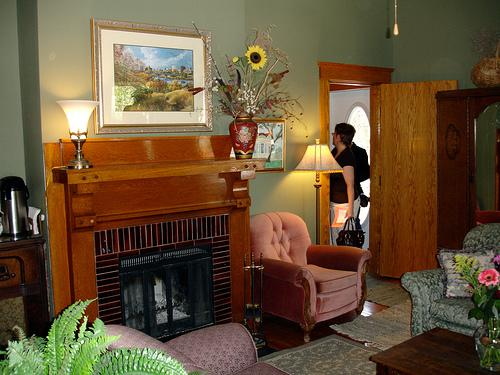Question: what color walls?
Choices:
A. Brown.
B. Green.
C. Tan.
D. White.
Answer with the letter. Answer: B Question: where is pink flower?
Choices:
A. Over the fireplace.
B. On the dresser.
C. On table.
D. In the window.
Answer with the letter. Answer: C Question: what is above fireplace?
Choices:
A. Flowers.
B. Painting.
C. An urn.
D. A clock.
Answer with the letter. Answer: B Question: where is sunflower?
Choices:
A. In window.
B. In a planter.
C. On the nightstand.
D. On mantle.
Answer with the letter. Answer: D Question: where woman standing?
Choices:
A. In the bedroom.
B. Doorway.
C. Over a bathroom sink.
D. By the stove.
Answer with the letter. Answer: B Question: who is holding purse?
Choices:
A. Woman.
B. Child.
C. Man.
D. Old woman.
Answer with the letter. Answer: A Question: how many lamps?
Choices:
A. Three.
B. Four.
C. Two.
D. Five.
Answer with the letter. Answer: C 